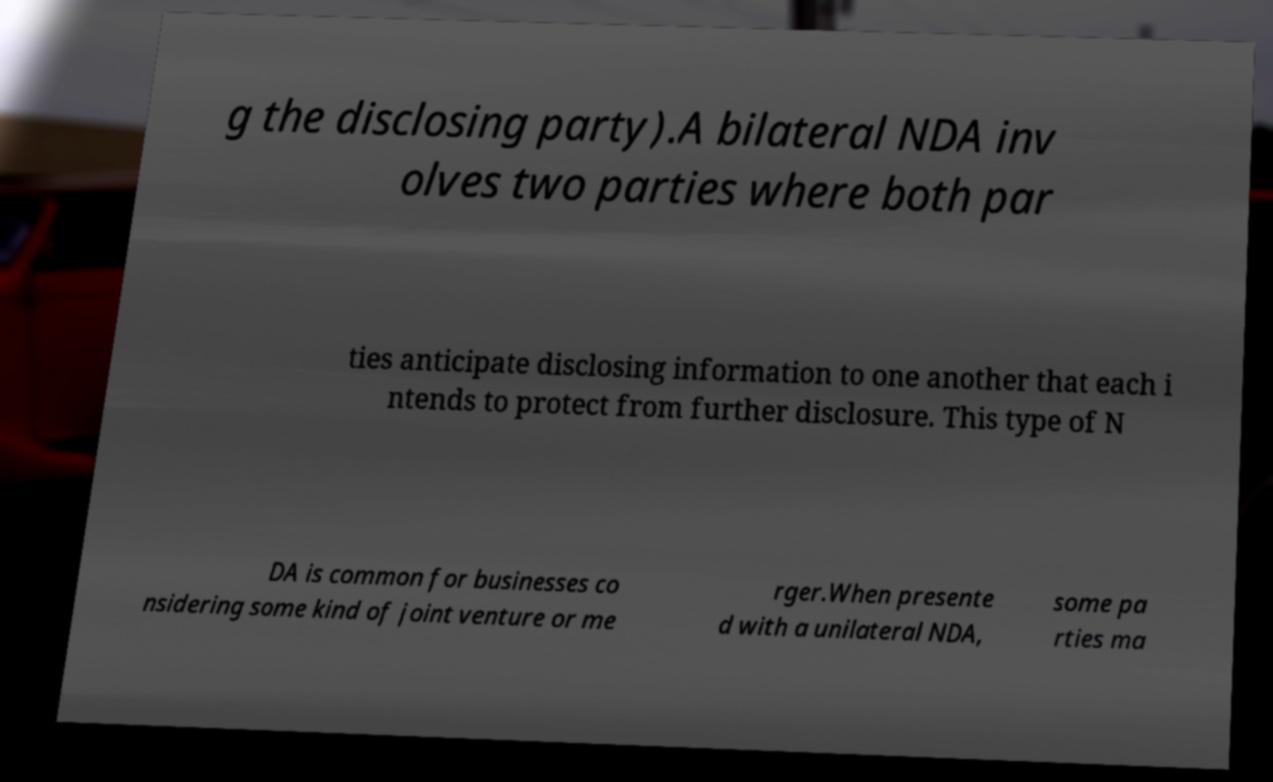Could you assist in decoding the text presented in this image and type it out clearly? g the disclosing party).A bilateral NDA inv olves two parties where both par ties anticipate disclosing information to one another that each i ntends to protect from further disclosure. This type of N DA is common for businesses co nsidering some kind of joint venture or me rger.When presente d with a unilateral NDA, some pa rties ma 